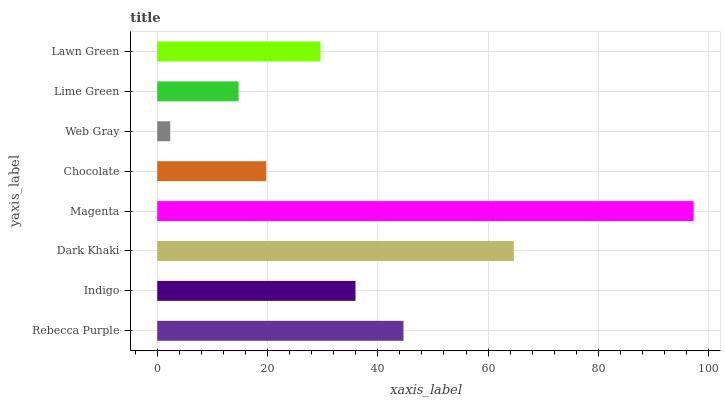Is Web Gray the minimum?
Answer yes or no. Yes. Is Magenta the maximum?
Answer yes or no. Yes. Is Indigo the minimum?
Answer yes or no. No. Is Indigo the maximum?
Answer yes or no. No. Is Rebecca Purple greater than Indigo?
Answer yes or no. Yes. Is Indigo less than Rebecca Purple?
Answer yes or no. Yes. Is Indigo greater than Rebecca Purple?
Answer yes or no. No. Is Rebecca Purple less than Indigo?
Answer yes or no. No. Is Indigo the high median?
Answer yes or no. Yes. Is Lawn Green the low median?
Answer yes or no. Yes. Is Lawn Green the high median?
Answer yes or no. No. Is Rebecca Purple the low median?
Answer yes or no. No. 